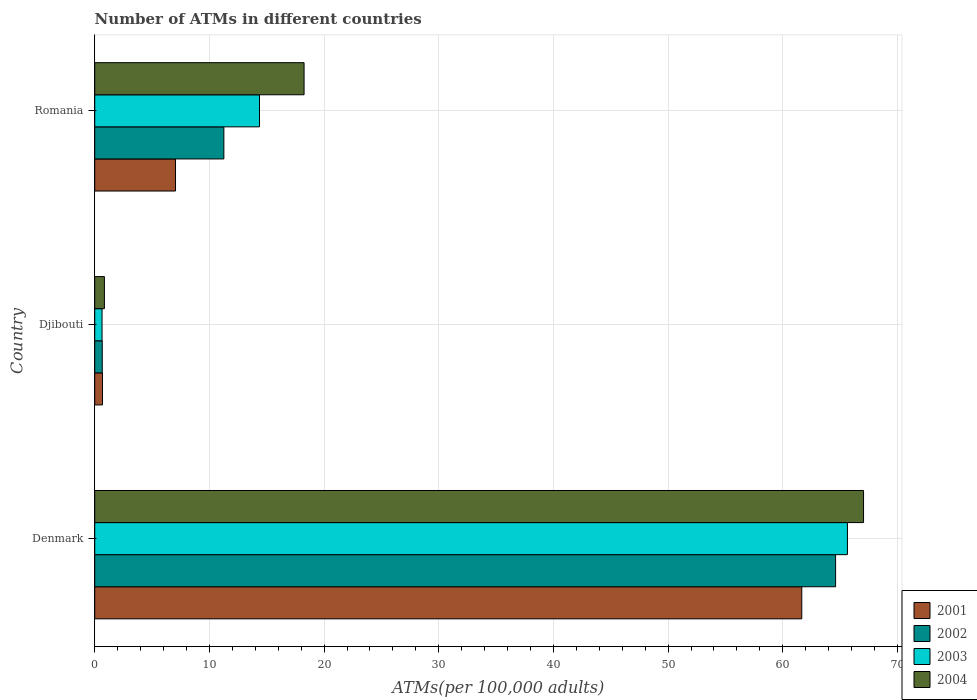Are the number of bars per tick equal to the number of legend labels?
Make the answer very short. Yes. What is the label of the 1st group of bars from the top?
Make the answer very short. Romania. What is the number of ATMs in 2001 in Djibouti?
Your answer should be compact. 0.68. Across all countries, what is the maximum number of ATMs in 2002?
Your answer should be compact. 64.61. Across all countries, what is the minimum number of ATMs in 2002?
Provide a succinct answer. 0.66. In which country was the number of ATMs in 2001 minimum?
Your answer should be very brief. Djibouti. What is the total number of ATMs in 2001 in the graph?
Provide a short and direct response. 69.38. What is the difference between the number of ATMs in 2003 in Denmark and that in Romania?
Your answer should be very brief. 51.27. What is the difference between the number of ATMs in 2004 in Denmark and the number of ATMs in 2001 in Djibouti?
Make the answer very short. 66.37. What is the average number of ATMs in 2002 per country?
Your response must be concise. 25.51. What is the difference between the number of ATMs in 2002 and number of ATMs in 2001 in Denmark?
Provide a short and direct response. 2.95. What is the ratio of the number of ATMs in 2002 in Denmark to that in Djibouti?
Offer a very short reply. 98.45. Is the difference between the number of ATMs in 2002 in Denmark and Romania greater than the difference between the number of ATMs in 2001 in Denmark and Romania?
Provide a short and direct response. No. What is the difference between the highest and the second highest number of ATMs in 2002?
Offer a very short reply. 53.35. What is the difference between the highest and the lowest number of ATMs in 2003?
Make the answer very short. 65. In how many countries, is the number of ATMs in 2004 greater than the average number of ATMs in 2004 taken over all countries?
Your answer should be very brief. 1. Is it the case that in every country, the sum of the number of ATMs in 2002 and number of ATMs in 2004 is greater than the sum of number of ATMs in 2001 and number of ATMs in 2003?
Provide a short and direct response. No. Is it the case that in every country, the sum of the number of ATMs in 2003 and number of ATMs in 2002 is greater than the number of ATMs in 2004?
Offer a terse response. Yes. How many countries are there in the graph?
Offer a very short reply. 3. Are the values on the major ticks of X-axis written in scientific E-notation?
Provide a short and direct response. No. Does the graph contain grids?
Keep it short and to the point. Yes. How many legend labels are there?
Provide a short and direct response. 4. What is the title of the graph?
Provide a short and direct response. Number of ATMs in different countries. What is the label or title of the X-axis?
Provide a short and direct response. ATMs(per 100,0 adults). What is the label or title of the Y-axis?
Your answer should be compact. Country. What is the ATMs(per 100,000 adults) in 2001 in Denmark?
Give a very brief answer. 61.66. What is the ATMs(per 100,000 adults) in 2002 in Denmark?
Offer a very short reply. 64.61. What is the ATMs(per 100,000 adults) in 2003 in Denmark?
Ensure brevity in your answer.  65.64. What is the ATMs(per 100,000 adults) in 2004 in Denmark?
Your answer should be compact. 67.04. What is the ATMs(per 100,000 adults) in 2001 in Djibouti?
Provide a short and direct response. 0.68. What is the ATMs(per 100,000 adults) of 2002 in Djibouti?
Give a very brief answer. 0.66. What is the ATMs(per 100,000 adults) of 2003 in Djibouti?
Your answer should be very brief. 0.64. What is the ATMs(per 100,000 adults) of 2004 in Djibouti?
Your answer should be very brief. 0.84. What is the ATMs(per 100,000 adults) of 2001 in Romania?
Keep it short and to the point. 7.04. What is the ATMs(per 100,000 adults) of 2002 in Romania?
Offer a very short reply. 11.26. What is the ATMs(per 100,000 adults) of 2003 in Romania?
Ensure brevity in your answer.  14.37. What is the ATMs(per 100,000 adults) in 2004 in Romania?
Offer a terse response. 18.26. Across all countries, what is the maximum ATMs(per 100,000 adults) of 2001?
Your response must be concise. 61.66. Across all countries, what is the maximum ATMs(per 100,000 adults) of 2002?
Make the answer very short. 64.61. Across all countries, what is the maximum ATMs(per 100,000 adults) in 2003?
Keep it short and to the point. 65.64. Across all countries, what is the maximum ATMs(per 100,000 adults) in 2004?
Your answer should be very brief. 67.04. Across all countries, what is the minimum ATMs(per 100,000 adults) of 2001?
Offer a terse response. 0.68. Across all countries, what is the minimum ATMs(per 100,000 adults) of 2002?
Your answer should be very brief. 0.66. Across all countries, what is the minimum ATMs(per 100,000 adults) in 2003?
Keep it short and to the point. 0.64. Across all countries, what is the minimum ATMs(per 100,000 adults) of 2004?
Offer a terse response. 0.84. What is the total ATMs(per 100,000 adults) of 2001 in the graph?
Your answer should be compact. 69.38. What is the total ATMs(per 100,000 adults) of 2002 in the graph?
Provide a succinct answer. 76.52. What is the total ATMs(per 100,000 adults) in 2003 in the graph?
Your answer should be very brief. 80.65. What is the total ATMs(per 100,000 adults) in 2004 in the graph?
Keep it short and to the point. 86.14. What is the difference between the ATMs(per 100,000 adults) in 2001 in Denmark and that in Djibouti?
Offer a terse response. 60.98. What is the difference between the ATMs(per 100,000 adults) of 2002 in Denmark and that in Djibouti?
Provide a short and direct response. 63.95. What is the difference between the ATMs(per 100,000 adults) of 2003 in Denmark and that in Djibouti?
Your answer should be very brief. 65. What is the difference between the ATMs(per 100,000 adults) in 2004 in Denmark and that in Djibouti?
Give a very brief answer. 66.2. What is the difference between the ATMs(per 100,000 adults) in 2001 in Denmark and that in Romania?
Your response must be concise. 54.61. What is the difference between the ATMs(per 100,000 adults) of 2002 in Denmark and that in Romania?
Your response must be concise. 53.35. What is the difference between the ATMs(per 100,000 adults) in 2003 in Denmark and that in Romania?
Provide a succinct answer. 51.27. What is the difference between the ATMs(per 100,000 adults) of 2004 in Denmark and that in Romania?
Your answer should be compact. 48.79. What is the difference between the ATMs(per 100,000 adults) in 2001 in Djibouti and that in Romania?
Your answer should be compact. -6.37. What is the difference between the ATMs(per 100,000 adults) in 2002 in Djibouti and that in Romania?
Provide a succinct answer. -10.6. What is the difference between the ATMs(per 100,000 adults) of 2003 in Djibouti and that in Romania?
Offer a terse response. -13.73. What is the difference between the ATMs(per 100,000 adults) of 2004 in Djibouti and that in Romania?
Provide a succinct answer. -17.41. What is the difference between the ATMs(per 100,000 adults) of 2001 in Denmark and the ATMs(per 100,000 adults) of 2002 in Djibouti?
Make the answer very short. 61. What is the difference between the ATMs(per 100,000 adults) in 2001 in Denmark and the ATMs(per 100,000 adults) in 2003 in Djibouti?
Offer a terse response. 61.02. What is the difference between the ATMs(per 100,000 adults) in 2001 in Denmark and the ATMs(per 100,000 adults) in 2004 in Djibouti?
Give a very brief answer. 60.81. What is the difference between the ATMs(per 100,000 adults) in 2002 in Denmark and the ATMs(per 100,000 adults) in 2003 in Djibouti?
Your answer should be compact. 63.97. What is the difference between the ATMs(per 100,000 adults) of 2002 in Denmark and the ATMs(per 100,000 adults) of 2004 in Djibouti?
Keep it short and to the point. 63.76. What is the difference between the ATMs(per 100,000 adults) in 2003 in Denmark and the ATMs(per 100,000 adults) in 2004 in Djibouti?
Offer a terse response. 64.79. What is the difference between the ATMs(per 100,000 adults) in 2001 in Denmark and the ATMs(per 100,000 adults) in 2002 in Romania?
Your answer should be very brief. 50.4. What is the difference between the ATMs(per 100,000 adults) in 2001 in Denmark and the ATMs(per 100,000 adults) in 2003 in Romania?
Provide a succinct answer. 47.29. What is the difference between the ATMs(per 100,000 adults) of 2001 in Denmark and the ATMs(per 100,000 adults) of 2004 in Romania?
Provide a succinct answer. 43.4. What is the difference between the ATMs(per 100,000 adults) of 2002 in Denmark and the ATMs(per 100,000 adults) of 2003 in Romania?
Give a very brief answer. 50.24. What is the difference between the ATMs(per 100,000 adults) of 2002 in Denmark and the ATMs(per 100,000 adults) of 2004 in Romania?
Your response must be concise. 46.35. What is the difference between the ATMs(per 100,000 adults) of 2003 in Denmark and the ATMs(per 100,000 adults) of 2004 in Romania?
Your answer should be very brief. 47.38. What is the difference between the ATMs(per 100,000 adults) in 2001 in Djibouti and the ATMs(per 100,000 adults) in 2002 in Romania?
Your response must be concise. -10.58. What is the difference between the ATMs(per 100,000 adults) in 2001 in Djibouti and the ATMs(per 100,000 adults) in 2003 in Romania?
Offer a very short reply. -13.69. What is the difference between the ATMs(per 100,000 adults) in 2001 in Djibouti and the ATMs(per 100,000 adults) in 2004 in Romania?
Make the answer very short. -17.58. What is the difference between the ATMs(per 100,000 adults) of 2002 in Djibouti and the ATMs(per 100,000 adults) of 2003 in Romania?
Give a very brief answer. -13.71. What is the difference between the ATMs(per 100,000 adults) of 2002 in Djibouti and the ATMs(per 100,000 adults) of 2004 in Romania?
Provide a short and direct response. -17.6. What is the difference between the ATMs(per 100,000 adults) of 2003 in Djibouti and the ATMs(per 100,000 adults) of 2004 in Romania?
Provide a succinct answer. -17.62. What is the average ATMs(per 100,000 adults) in 2001 per country?
Offer a very short reply. 23.13. What is the average ATMs(per 100,000 adults) in 2002 per country?
Your answer should be very brief. 25.51. What is the average ATMs(per 100,000 adults) of 2003 per country?
Ensure brevity in your answer.  26.88. What is the average ATMs(per 100,000 adults) of 2004 per country?
Offer a very short reply. 28.71. What is the difference between the ATMs(per 100,000 adults) in 2001 and ATMs(per 100,000 adults) in 2002 in Denmark?
Offer a very short reply. -2.95. What is the difference between the ATMs(per 100,000 adults) in 2001 and ATMs(per 100,000 adults) in 2003 in Denmark?
Your answer should be very brief. -3.98. What is the difference between the ATMs(per 100,000 adults) of 2001 and ATMs(per 100,000 adults) of 2004 in Denmark?
Offer a very short reply. -5.39. What is the difference between the ATMs(per 100,000 adults) of 2002 and ATMs(per 100,000 adults) of 2003 in Denmark?
Provide a succinct answer. -1.03. What is the difference between the ATMs(per 100,000 adults) in 2002 and ATMs(per 100,000 adults) in 2004 in Denmark?
Keep it short and to the point. -2.44. What is the difference between the ATMs(per 100,000 adults) in 2003 and ATMs(per 100,000 adults) in 2004 in Denmark?
Your answer should be compact. -1.41. What is the difference between the ATMs(per 100,000 adults) of 2001 and ATMs(per 100,000 adults) of 2002 in Djibouti?
Provide a succinct answer. 0.02. What is the difference between the ATMs(per 100,000 adults) of 2001 and ATMs(per 100,000 adults) of 2003 in Djibouti?
Provide a short and direct response. 0.04. What is the difference between the ATMs(per 100,000 adults) of 2001 and ATMs(per 100,000 adults) of 2004 in Djibouti?
Provide a succinct answer. -0.17. What is the difference between the ATMs(per 100,000 adults) of 2002 and ATMs(per 100,000 adults) of 2003 in Djibouti?
Offer a very short reply. 0.02. What is the difference between the ATMs(per 100,000 adults) in 2002 and ATMs(per 100,000 adults) in 2004 in Djibouti?
Your answer should be compact. -0.19. What is the difference between the ATMs(per 100,000 adults) in 2003 and ATMs(per 100,000 adults) in 2004 in Djibouti?
Your answer should be compact. -0.21. What is the difference between the ATMs(per 100,000 adults) of 2001 and ATMs(per 100,000 adults) of 2002 in Romania?
Provide a succinct answer. -4.21. What is the difference between the ATMs(per 100,000 adults) of 2001 and ATMs(per 100,000 adults) of 2003 in Romania?
Provide a short and direct response. -7.32. What is the difference between the ATMs(per 100,000 adults) in 2001 and ATMs(per 100,000 adults) in 2004 in Romania?
Keep it short and to the point. -11.21. What is the difference between the ATMs(per 100,000 adults) of 2002 and ATMs(per 100,000 adults) of 2003 in Romania?
Ensure brevity in your answer.  -3.11. What is the difference between the ATMs(per 100,000 adults) in 2002 and ATMs(per 100,000 adults) in 2004 in Romania?
Offer a very short reply. -7. What is the difference between the ATMs(per 100,000 adults) of 2003 and ATMs(per 100,000 adults) of 2004 in Romania?
Offer a very short reply. -3.89. What is the ratio of the ATMs(per 100,000 adults) in 2001 in Denmark to that in Djibouti?
Make the answer very short. 91.18. What is the ratio of the ATMs(per 100,000 adults) in 2002 in Denmark to that in Djibouti?
Make the answer very short. 98.45. What is the ratio of the ATMs(per 100,000 adults) in 2003 in Denmark to that in Djibouti?
Ensure brevity in your answer.  102.88. What is the ratio of the ATMs(per 100,000 adults) in 2004 in Denmark to that in Djibouti?
Offer a very short reply. 79.46. What is the ratio of the ATMs(per 100,000 adults) of 2001 in Denmark to that in Romania?
Keep it short and to the point. 8.75. What is the ratio of the ATMs(per 100,000 adults) in 2002 in Denmark to that in Romania?
Your answer should be compact. 5.74. What is the ratio of the ATMs(per 100,000 adults) in 2003 in Denmark to that in Romania?
Your answer should be compact. 4.57. What is the ratio of the ATMs(per 100,000 adults) of 2004 in Denmark to that in Romania?
Make the answer very short. 3.67. What is the ratio of the ATMs(per 100,000 adults) of 2001 in Djibouti to that in Romania?
Provide a short and direct response. 0.1. What is the ratio of the ATMs(per 100,000 adults) of 2002 in Djibouti to that in Romania?
Your answer should be very brief. 0.06. What is the ratio of the ATMs(per 100,000 adults) of 2003 in Djibouti to that in Romania?
Provide a succinct answer. 0.04. What is the ratio of the ATMs(per 100,000 adults) in 2004 in Djibouti to that in Romania?
Offer a terse response. 0.05. What is the difference between the highest and the second highest ATMs(per 100,000 adults) of 2001?
Offer a terse response. 54.61. What is the difference between the highest and the second highest ATMs(per 100,000 adults) of 2002?
Offer a very short reply. 53.35. What is the difference between the highest and the second highest ATMs(per 100,000 adults) in 2003?
Give a very brief answer. 51.27. What is the difference between the highest and the second highest ATMs(per 100,000 adults) of 2004?
Provide a short and direct response. 48.79. What is the difference between the highest and the lowest ATMs(per 100,000 adults) in 2001?
Offer a terse response. 60.98. What is the difference between the highest and the lowest ATMs(per 100,000 adults) in 2002?
Your answer should be very brief. 63.95. What is the difference between the highest and the lowest ATMs(per 100,000 adults) in 2003?
Ensure brevity in your answer.  65. What is the difference between the highest and the lowest ATMs(per 100,000 adults) in 2004?
Provide a short and direct response. 66.2. 